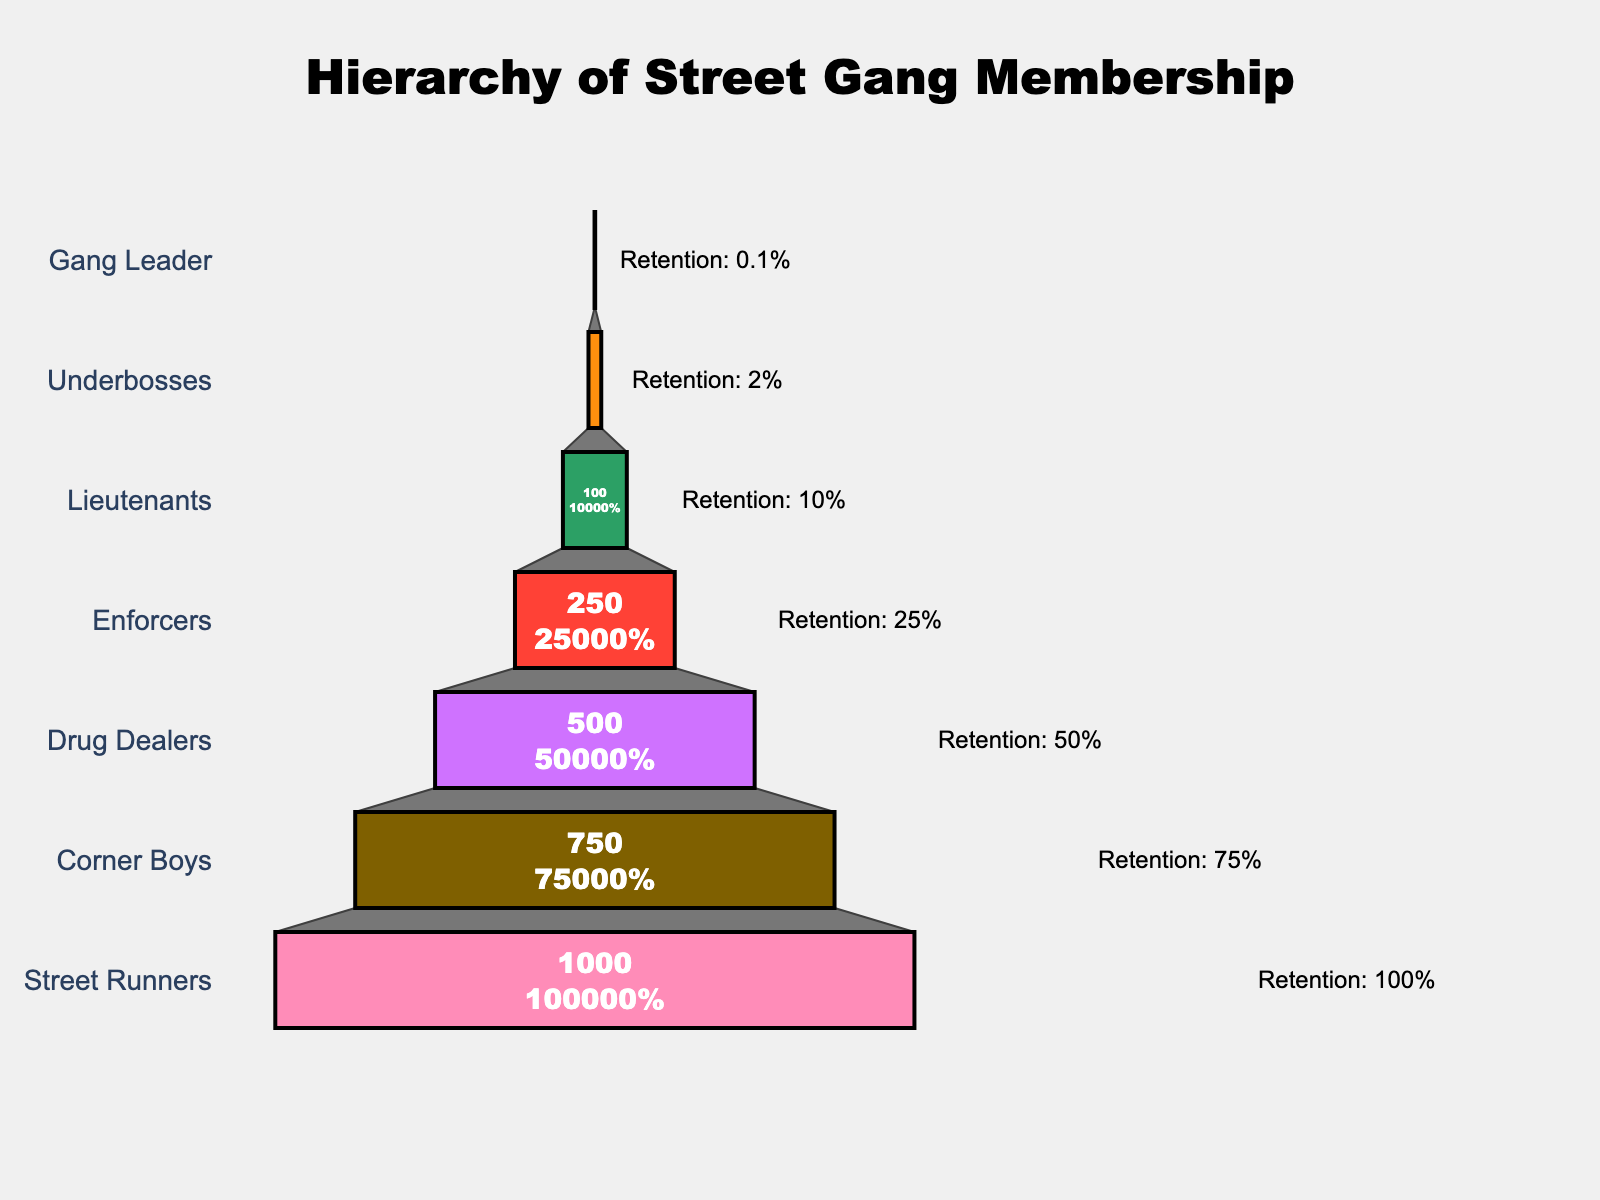How many levels are there in the street gang hierarchy? Count the number of unique levels listed in the funnel chart.
Answer: 7 What is the title of the chart? Look at the top of the chart to find its title.
Answer: Hierarchy of Street Gang Membership Which level has the highest number of members? The funnel chart makes it easy to compare the number of members visually. Look at the widest segment.
Answer: Street Runners What percentage of members are retained at the Lieutenants level? The funnel chart includes retention rates as annotations next to each level. Find the value next to "Lieutenants".
Answer: 10% How many members advance from the Corner Boys level to the Drug Dealers level? Subtract the number of Drug Dealers from the number of Corner Boys. 750 - 500 = 250
Answer: 250 Which level experiences the greatest decline in membership numbers? Compare the change in number of members between each level. The greatest drop is from Corner Boys to Drug Dealers (750 - 500 = 250).
Answer: Corner Boys to Drug Dealers What proportion of Enforcers make it to the Underbosses level? Calculate the proportion by dividing the number of Underbosses by Enforcers and multiply by 100. (20 / 250) * 100 = 8%.
Answer: 8% How does the retention rate change as you move up the hierarchy? The retention rate generally decreases as you move from lower to higher levels in the hierarchy.
Answer: Decreases What is the retention rate for the Gang Leader level? Look at the annotation next to the "Gang Leader" level in the funnel chart to find the value.
Answer: 0.1% Compare the number of members at the Drug Dealers level and Lieutenants level. Which is higher? Refer to the funnel chart and see which segment is wider. Drug Dealers: 500, Lieutenants: 100.
Answer: Drug Dealers 